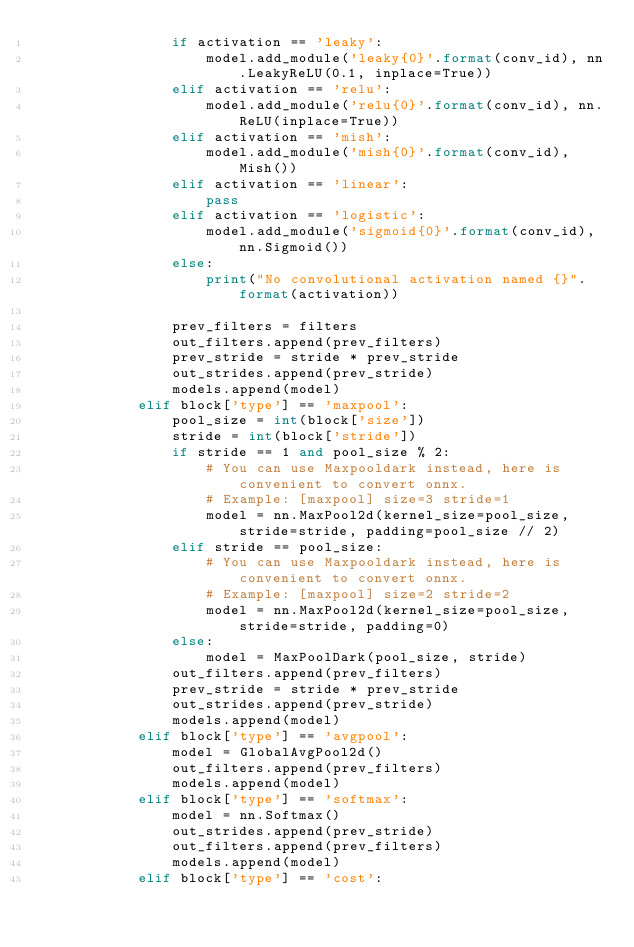Convert code to text. <code><loc_0><loc_0><loc_500><loc_500><_Python_>                if activation == 'leaky':
                    model.add_module('leaky{0}'.format(conv_id), nn.LeakyReLU(0.1, inplace=True))
                elif activation == 'relu':
                    model.add_module('relu{0}'.format(conv_id), nn.ReLU(inplace=True))
                elif activation == 'mish':
                    model.add_module('mish{0}'.format(conv_id), Mish())
                elif activation == 'linear':
                    pass
                elif activation == 'logistic':
                    model.add_module('sigmoid{0}'.format(conv_id), nn.Sigmoid())
                else:
                    print("No convolutional activation named {}".format(activation))

                prev_filters = filters
                out_filters.append(prev_filters)
                prev_stride = stride * prev_stride
                out_strides.append(prev_stride)
                models.append(model)
            elif block['type'] == 'maxpool':
                pool_size = int(block['size'])
                stride = int(block['stride'])
                if stride == 1 and pool_size % 2:
                    # You can use Maxpooldark instead, here is convenient to convert onnx.
                    # Example: [maxpool] size=3 stride=1
                    model = nn.MaxPool2d(kernel_size=pool_size, stride=stride, padding=pool_size // 2)
                elif stride == pool_size:
                    # You can use Maxpooldark instead, here is convenient to convert onnx.
                    # Example: [maxpool] size=2 stride=2
                    model = nn.MaxPool2d(kernel_size=pool_size, stride=stride, padding=0)
                else:
                    model = MaxPoolDark(pool_size, stride)
                out_filters.append(prev_filters)
                prev_stride = stride * prev_stride
                out_strides.append(prev_stride)
                models.append(model)
            elif block['type'] == 'avgpool':
                model = GlobalAvgPool2d()
                out_filters.append(prev_filters)
                models.append(model)
            elif block['type'] == 'softmax':
                model = nn.Softmax()
                out_strides.append(prev_stride)
                out_filters.append(prev_filters)
                models.append(model)
            elif block['type'] == 'cost':</code> 